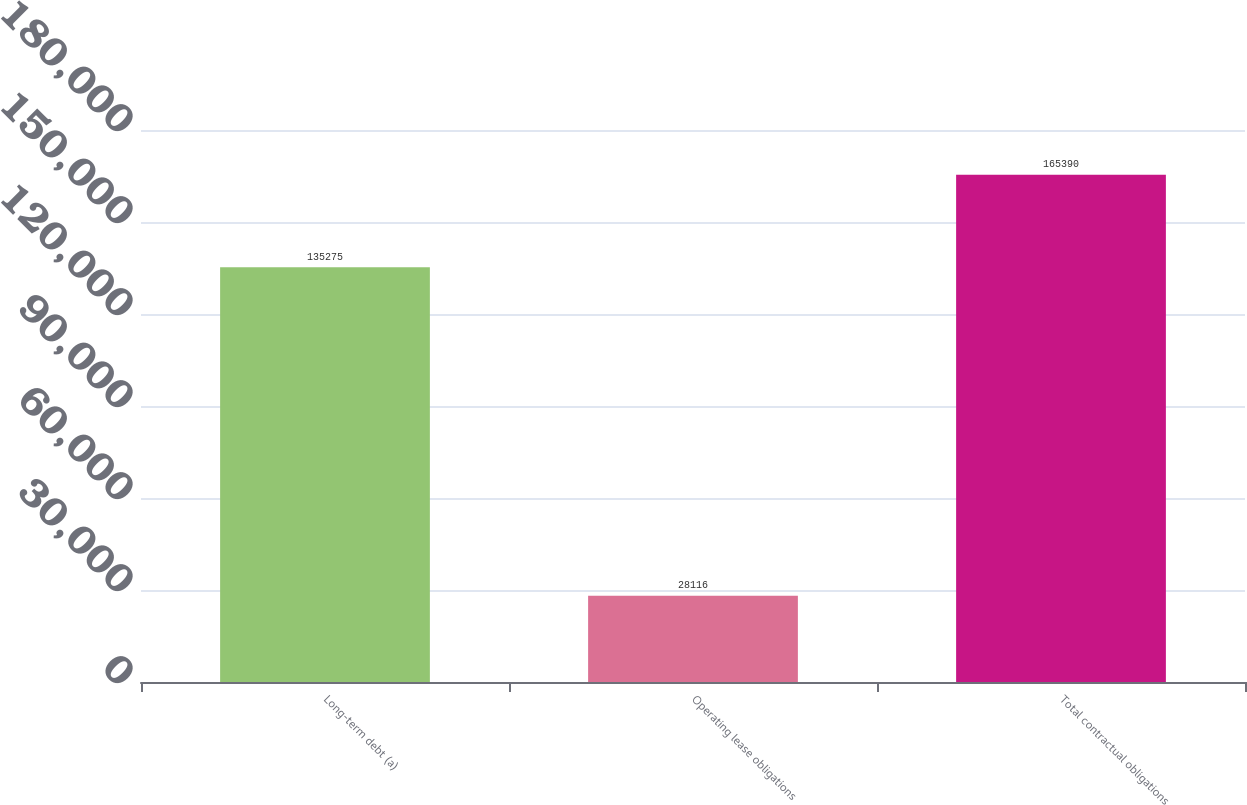<chart> <loc_0><loc_0><loc_500><loc_500><bar_chart><fcel>Long-term debt (a)<fcel>Operating lease obligations<fcel>Total contractual obligations<nl><fcel>135275<fcel>28116<fcel>165390<nl></chart> 